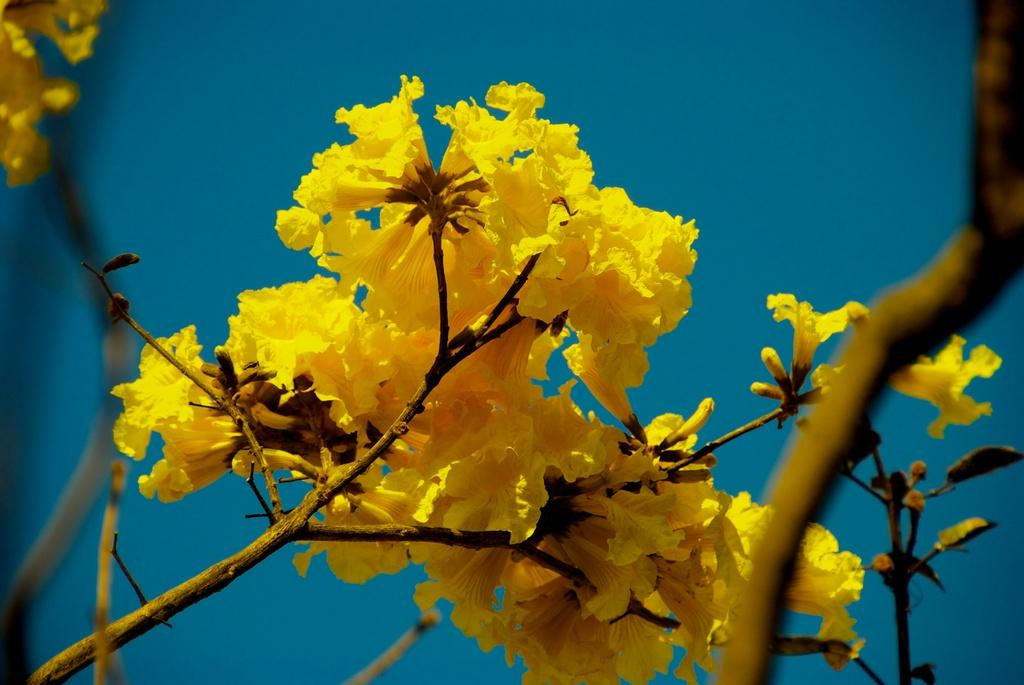What type of flowers are in the image? There are yellow flowers in the image. What part of the flowers connects them to the ground or a vase? The flowers have stems. What color is the background of the image? The background of the image is blue. Can you tell me how many pears are on the expert's ear in the image? There are no pears or experts present in the image; it features yellow flowers with stems against a blue background. 